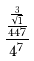<formula> <loc_0><loc_0><loc_500><loc_500>\frac { \frac { \frac { 3 } { \sqrt { 1 } } } { 4 4 7 } } { 4 ^ { 7 } }</formula> 